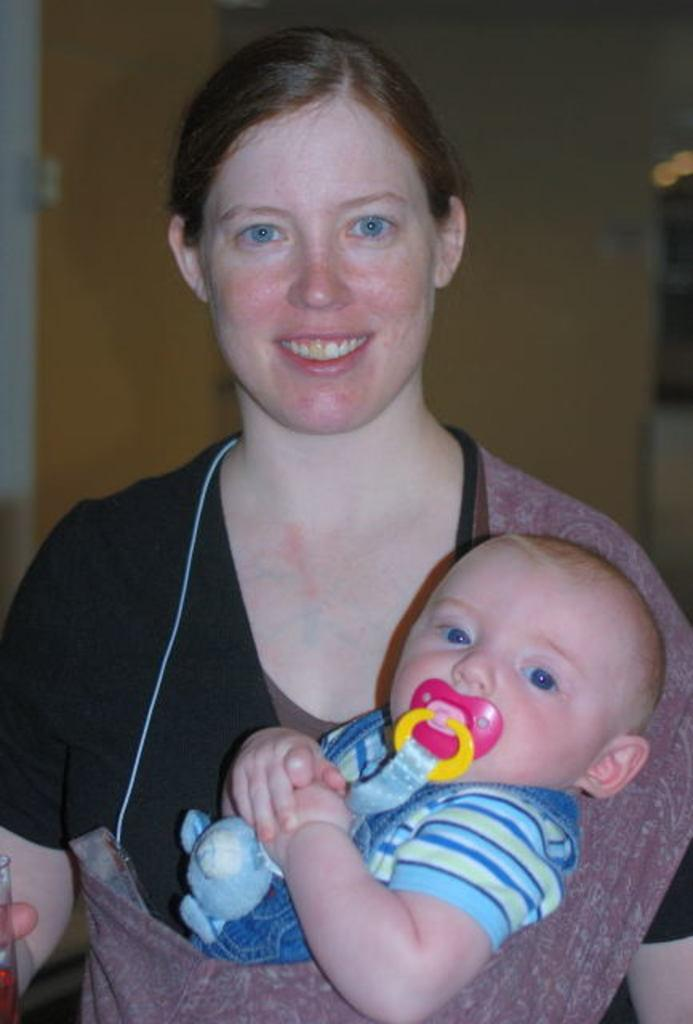Where was the image taken? The image is taken indoors. What can be seen in the background of the image? There is a wall in the background of the image. What is the woman in the image doing? The woman is standing in the middle of the image and holding a glass and a baby. Is there an umbrella visible in the image? No, there is no umbrella present in the image. How many ladybugs can be seen on the woman's shoulder in the image? There are no ladybugs visible in the image. 